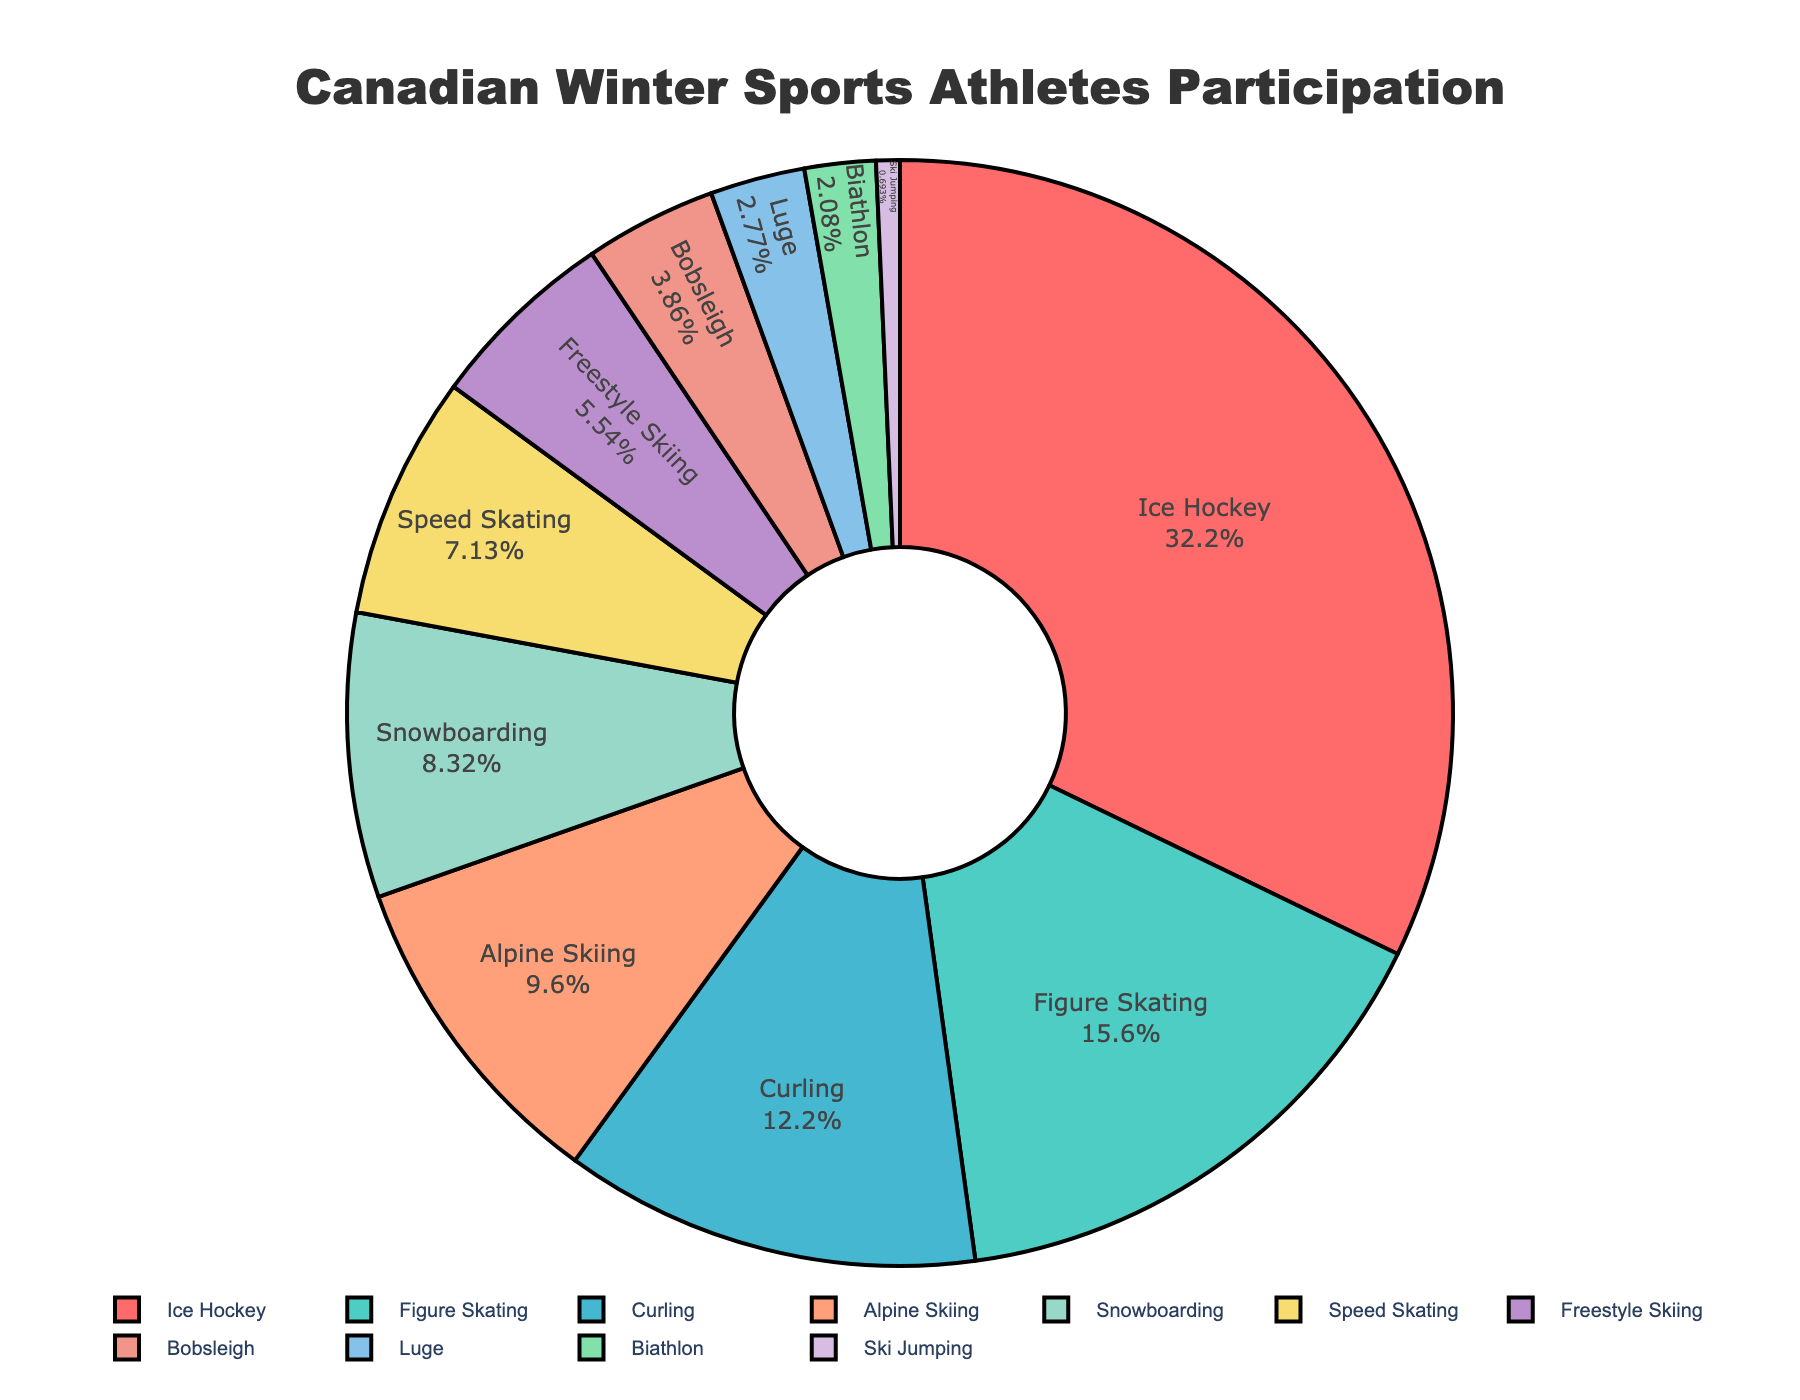Which sport has the highest percentage of Canadian athletes participating? The pie chart shows that Ice Hockey has the largest section, with 32.5% of the Canadian athletes participating in this sport.
Answer: Ice Hockey Which sport has the smallest percentage of Canadian athletes participating? The pie chart indicates that Ski Jumping has the smallest section, with only 0.7% of Canadian athletes participating in this sport.
Answer: Ski Jumping What percentage of Canadian athletes participate in both Figure Skating and Curling combined? We can find this by adding the percentages for Figure Skating (15.8%) and Curling (12.3%): 15.8% + 12.3% = 28.1%.
Answer: 28.1% How does the percentage of athletes in Alpine Skiing compare to those in Speed Skating? The pie chart shows that Alpine Skiing has 9.7% of athletes, while Speed Skating has 7.2%. Thus, Alpine Skiing has a higher percentage than Speed Skating.
Answer: Alpine Skiing What is the difference in percentage points between the athletes participating in Snowboarding and those in Bobsleigh? The chart indicates Snowboarding has 8.4%, and Bobsleigh has 3.9%. The difference is calculated as 8.4% - 3.9% = 4.5%.
Answer: 4.5% Are there more athletes participating in Freestyle Skiing or Luge? The chart shows Freestyle Skiing at 5.6% and Luge at 2.8%. Thus, more athletes participate in Freestyle Skiing.
Answer: Freestyle Skiing What two sports together make up approximately 20% of athlete participation? Looking at the chart, Curling (12.3%) and Alpine Skiing (9.7%) together make up 22%, while Freestyle Skiing (5.6%) and Speed Skating (7.2%) total 12.8%. The closest combination to 20% is Alpine Skiing (9.7%) and Snowboarding (8.4%), totaling 18.1%.
Answer: Alpine Skiing and Snowboarding How do the combined percentages of Ice Hockey, Figure Skating, and Curling compare to the rest of the sports? The total percentage for Ice Hockey (32.5%), Figure Skating (15.8%), and Curling (12.3%) is calculated as 32.5% + 15.8% + 12.3% = 60.6%. The rest of the sports make up 100% - 60.6% = 39.4%.
Answer: 60.6% vs. 39.4% 